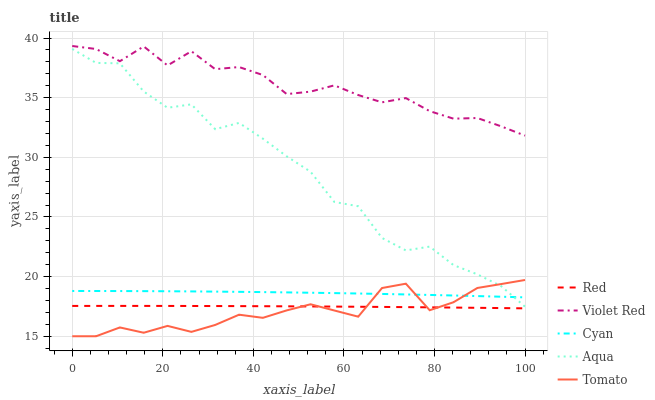Does Tomato have the minimum area under the curve?
Answer yes or no. Yes. Does Violet Red have the maximum area under the curve?
Answer yes or no. Yes. Does Cyan have the minimum area under the curve?
Answer yes or no. No. Does Cyan have the maximum area under the curve?
Answer yes or no. No. Is Red the smoothest?
Answer yes or no. Yes. Is Aqua the roughest?
Answer yes or no. Yes. Is Cyan the smoothest?
Answer yes or no. No. Is Cyan the roughest?
Answer yes or no. No. Does Tomato have the lowest value?
Answer yes or no. Yes. Does Cyan have the lowest value?
Answer yes or no. No. Does Violet Red have the highest value?
Answer yes or no. Yes. Does Cyan have the highest value?
Answer yes or no. No. Is Red less than Aqua?
Answer yes or no. Yes. Is Violet Red greater than Cyan?
Answer yes or no. Yes. Does Aqua intersect Tomato?
Answer yes or no. Yes. Is Aqua less than Tomato?
Answer yes or no. No. Is Aqua greater than Tomato?
Answer yes or no. No. Does Red intersect Aqua?
Answer yes or no. No. 